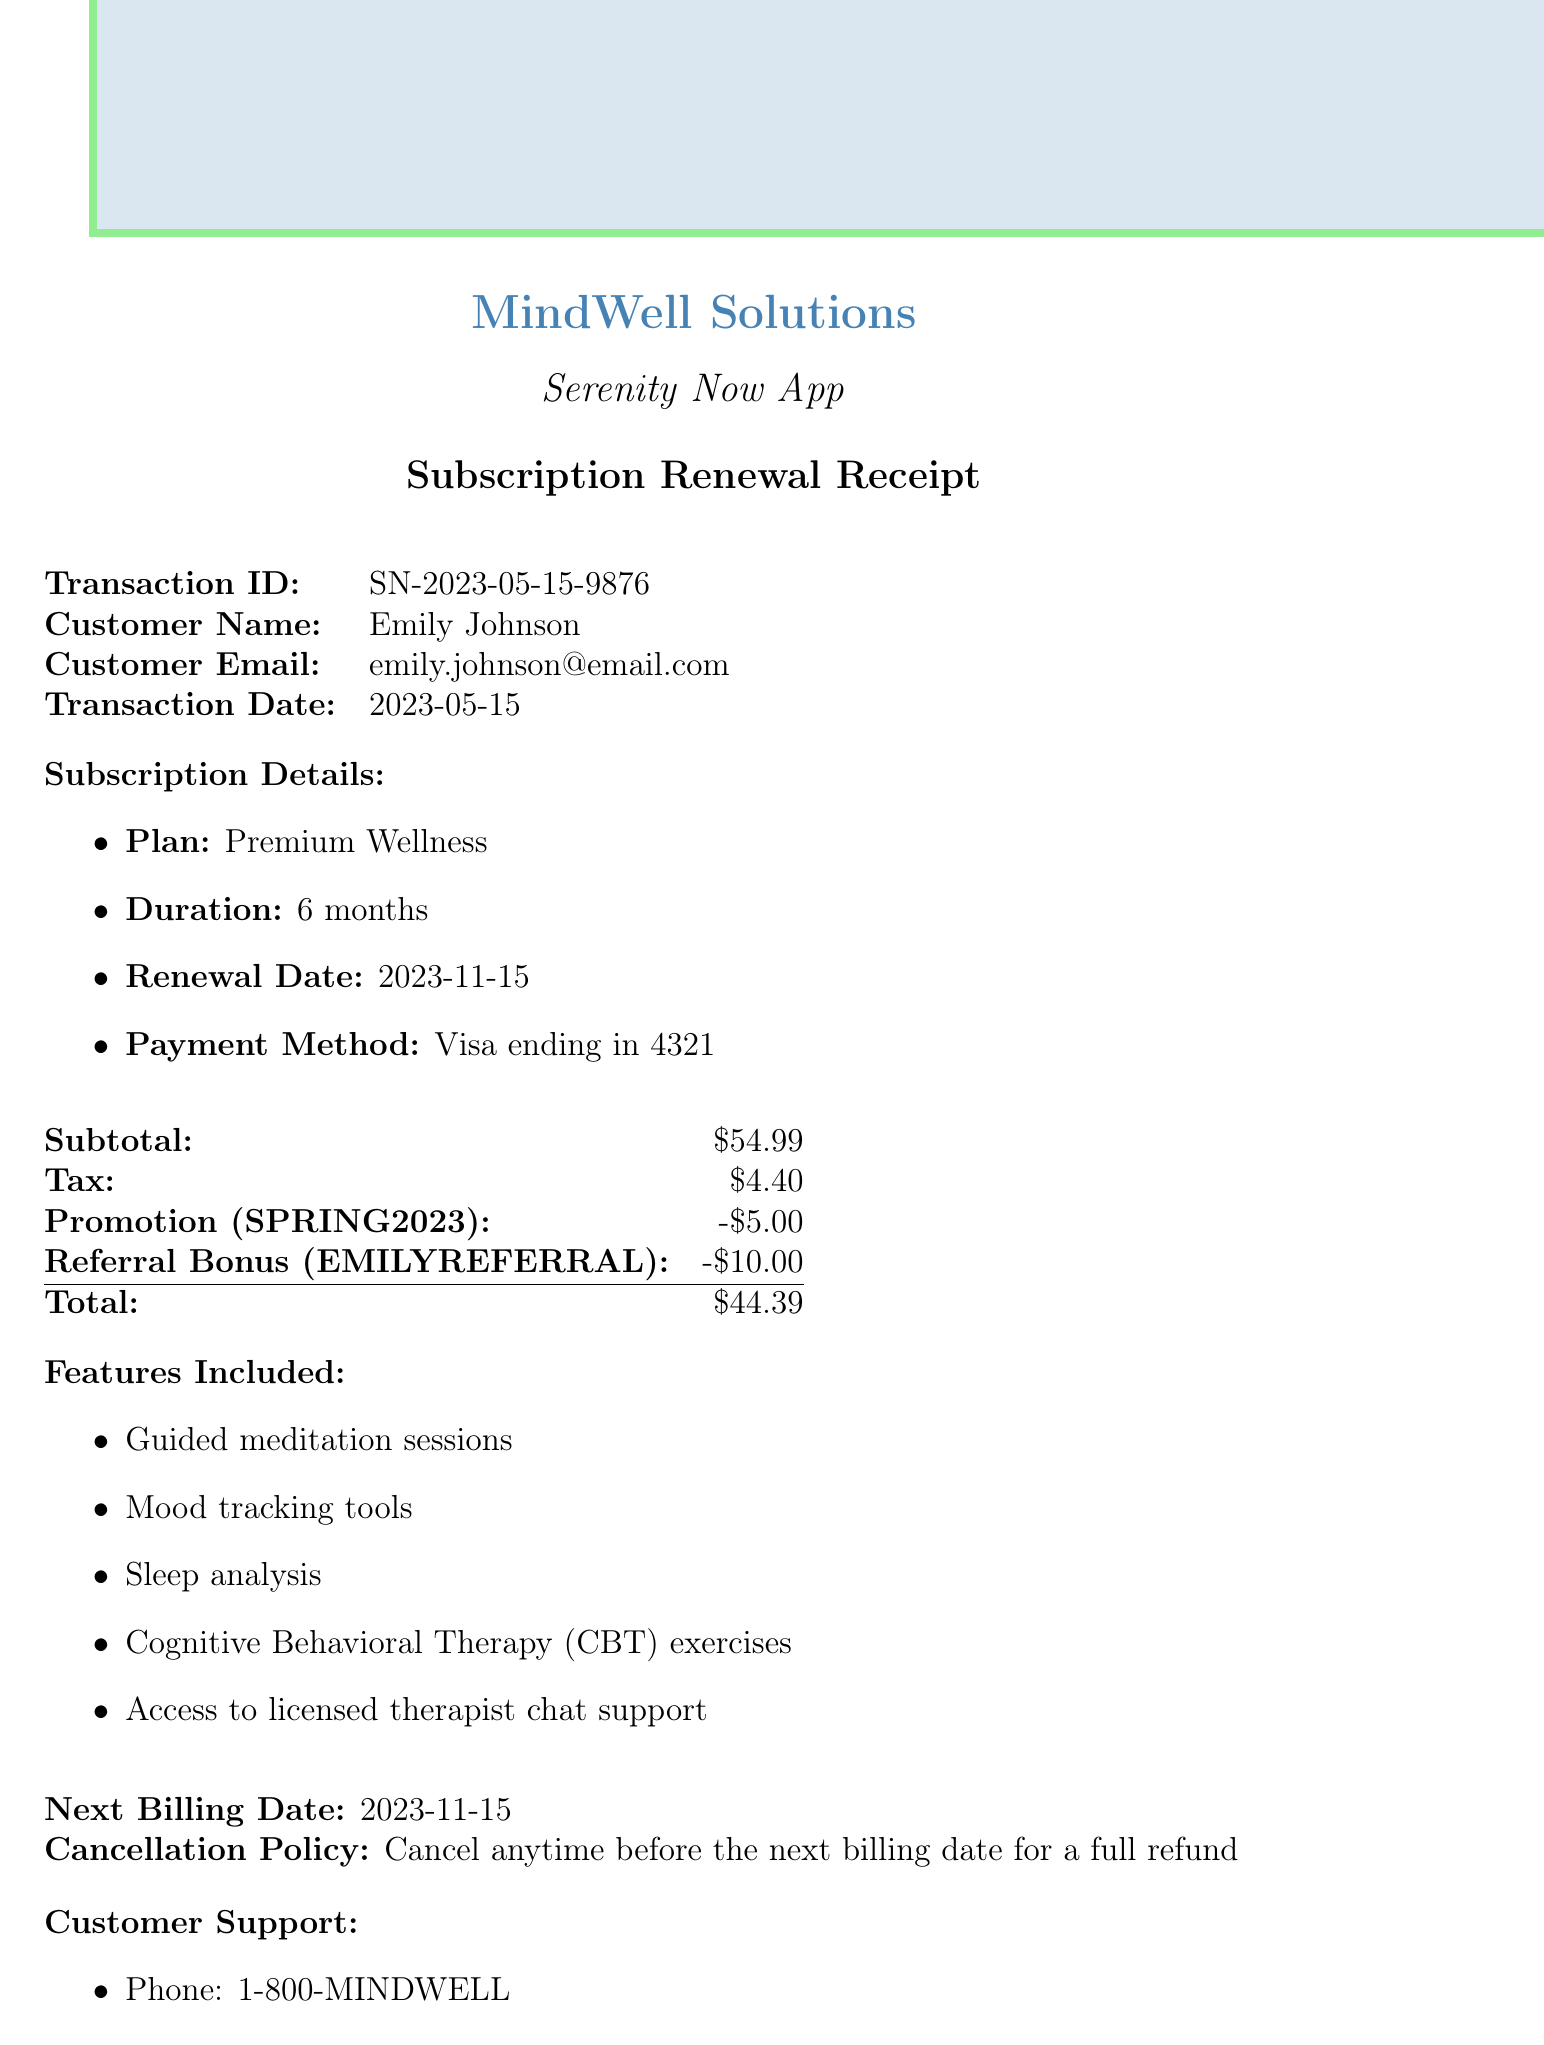What is the transaction ID? The transaction ID is specifically listed in the document for reference, which is SN-2023-05-15-9876.
Answer: SN-2023-05-15-9876 Who is the customer? The document clearly states the name of the customer who made the transaction, which is Emily Johnson.
Answer: Emily Johnson What is the selected subscription plan? The document details the chosen plan for the subscription renewal, which is Premium Wellness.
Answer: Premium Wellness What is the total amount charged? The total amount reflects the final price after discounts and taxes, which is $44.39.
Answer: $44.39 When is the renewal date? The renewal date indicates when the next billing for the subscription will occur, specified in the document as 2023-11-15.
Answer: 2023-11-15 What discount was applied? The document mentions a promotion discount that was utilized during the transaction, which amounts to $5.00.
Answer: $5.00 What features are included in the subscription? The document lists several features that come with the selected plan, including guided meditation sessions and mood tracking tools.
Answer: Guided meditation sessions, Mood tracking tools, Sleep analysis, Cognitive Behavioral Therapy (CBT) exercises, Access to licensed therapist chat support What is the cancellation policy? The document explicitly outlines the cancellation policy, stating the terms under which a refund can be received.
Answer: Cancel anytime before the next billing date for a full refund What are the customer support contact details? The document provides specific details for customer support including a phone number and email for service inquiries.
Answer: Phone: 1-800-MINDWELL, Email: support@serenitynow.com 